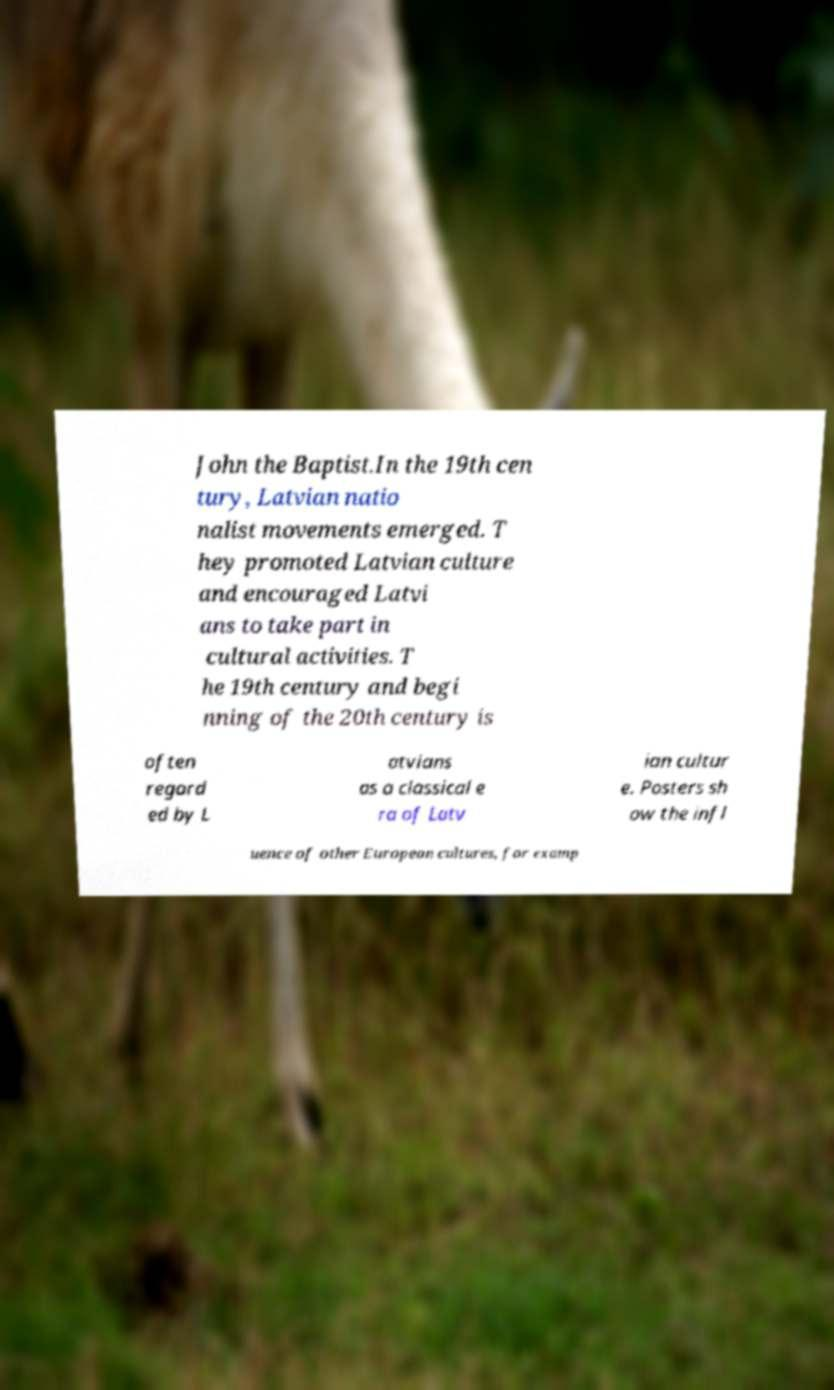Please read and relay the text visible in this image. What does it say? John the Baptist.In the 19th cen tury, Latvian natio nalist movements emerged. T hey promoted Latvian culture and encouraged Latvi ans to take part in cultural activities. T he 19th century and begi nning of the 20th century is often regard ed by L atvians as a classical e ra of Latv ian cultur e. Posters sh ow the infl uence of other European cultures, for examp 